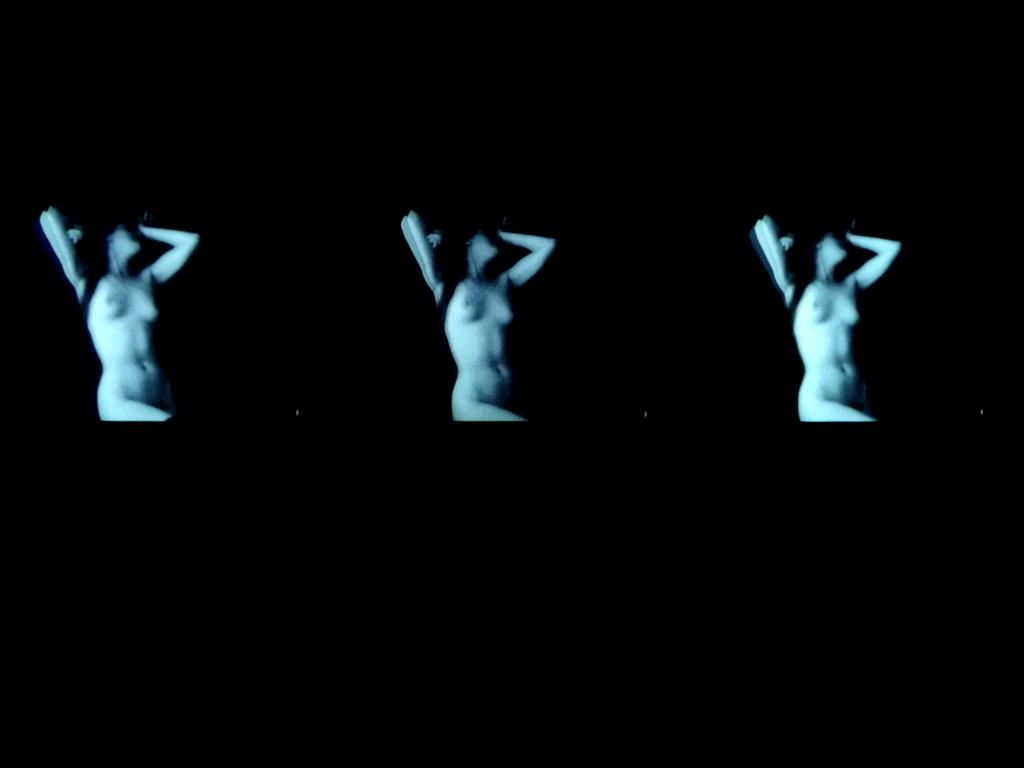How many people are in the image? There are three women in the image. Can you describe the lighting in the image? The image is in dark. What type of jellyfish can be seen swimming in the image? There is no jellyfish present in the image; it features three women. What is the condition of the women's throats in the image? There is no information about the women's throats in the image. 